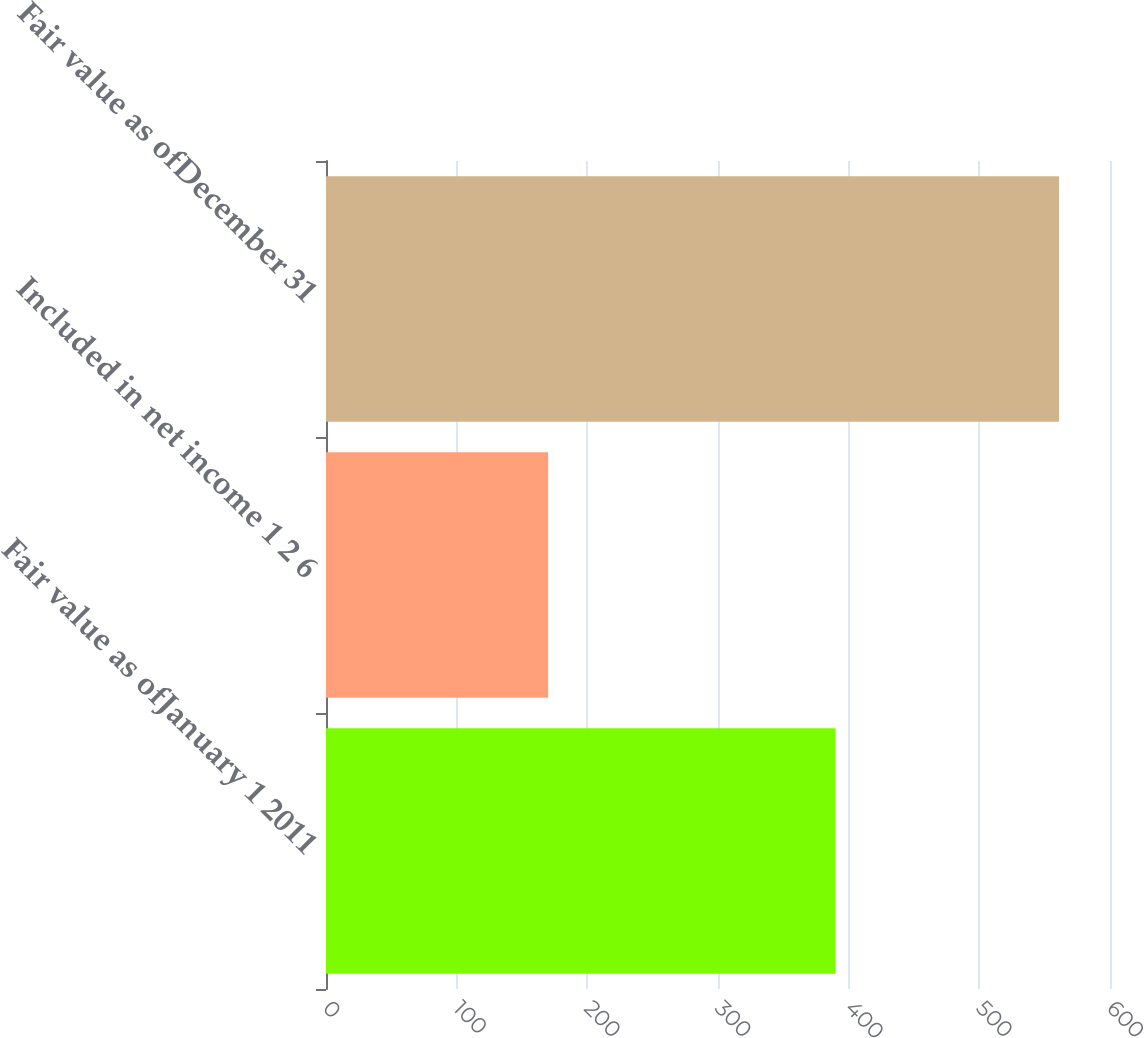<chart> <loc_0><loc_0><loc_500><loc_500><bar_chart><fcel>Fair value as ofJanuary 1 2011<fcel>Included in net income 1 2 6<fcel>Fair value as ofDecember 31<nl><fcel>390<fcel>170<fcel>561<nl></chart> 